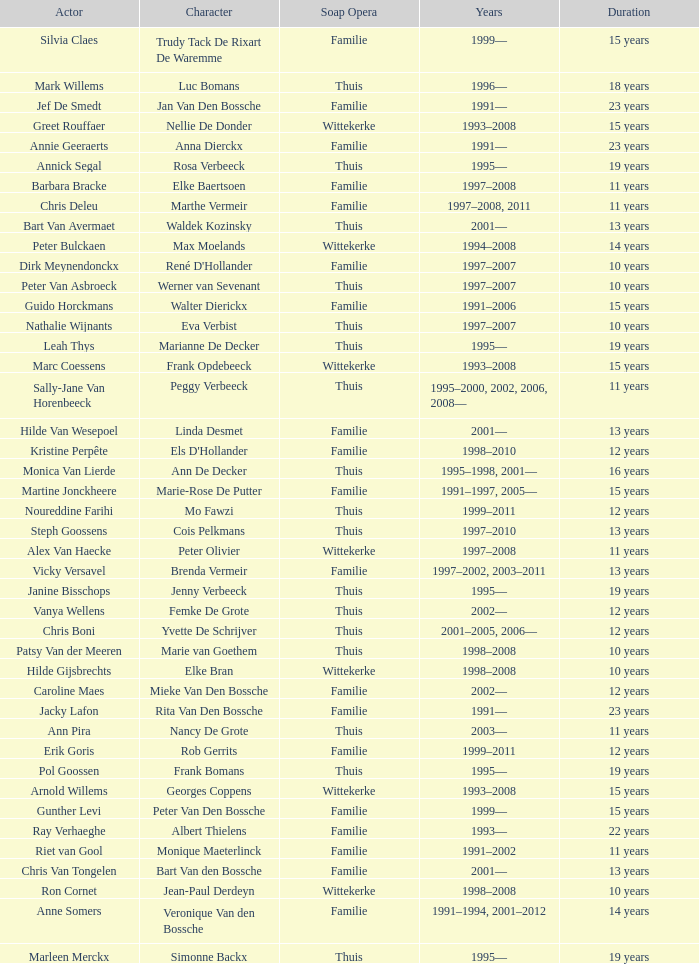What character did Vicky Versavel play for 13 years? Brenda Vermeir. 